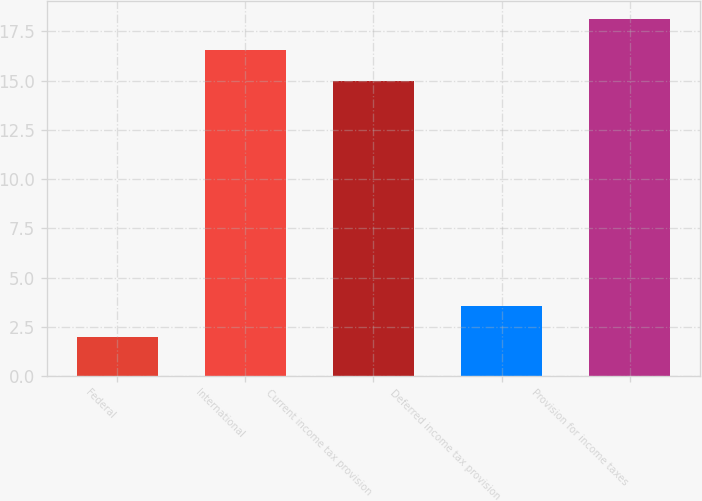Convert chart. <chart><loc_0><loc_0><loc_500><loc_500><bar_chart><fcel>Federal<fcel>International<fcel>Current income tax provision<fcel>Deferred income tax provision<fcel>Provision for income taxes<nl><fcel>2<fcel>16.57<fcel>15<fcel>3.57<fcel>18.14<nl></chart> 